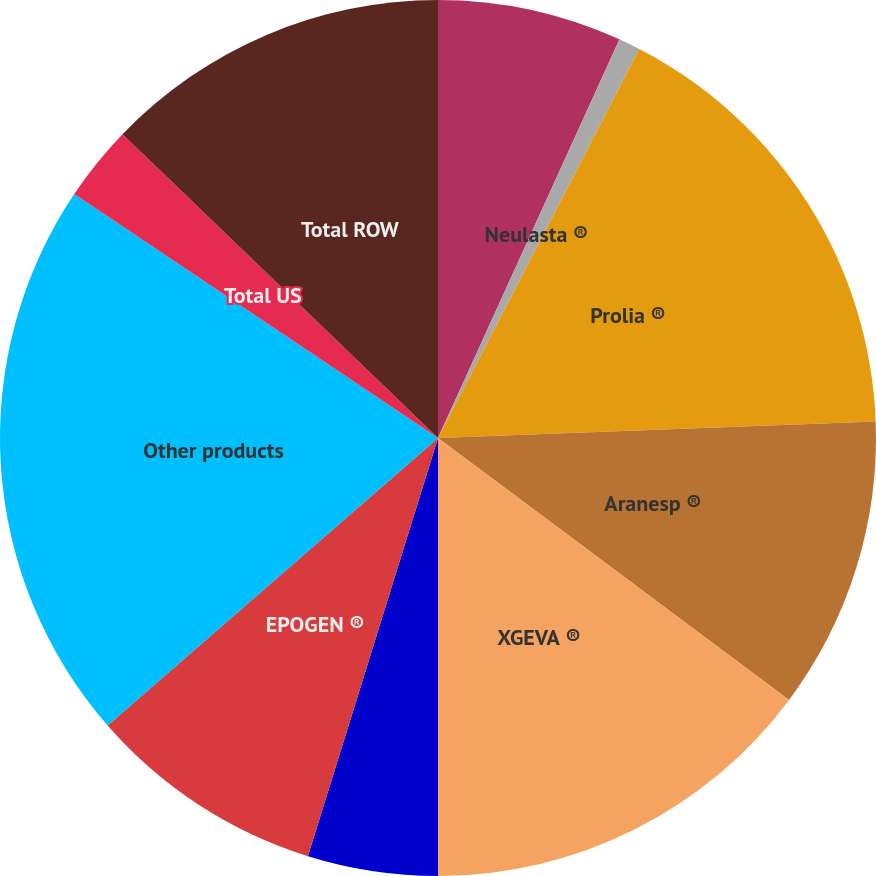Convert chart to OTSL. <chart><loc_0><loc_0><loc_500><loc_500><pie_chart><fcel>ENBREL<fcel>Neulasta ®<fcel>Prolia ®<fcel>Aranesp ®<fcel>XGEVA ®<fcel>Sensipar^®/Mimpara ®<fcel>EPOGEN ®<fcel>Other products<fcel>Total US<fcel>Total ROW<nl><fcel>6.8%<fcel>0.8%<fcel>16.8%<fcel>10.8%<fcel>14.8%<fcel>4.8%<fcel>8.8%<fcel>20.8%<fcel>2.8%<fcel>12.8%<nl></chart> 